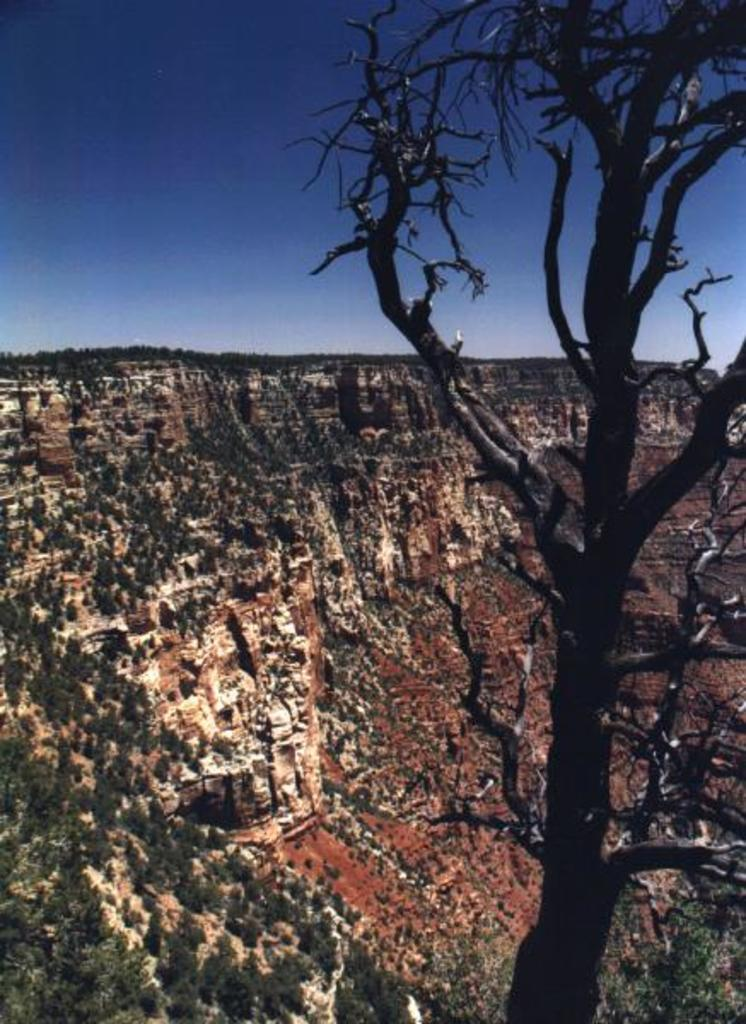What type of vegetation is located on the right side of the image? There is a tree on the right side of the image. What geographical feature can be seen in the background of the image? There is a mountain in the background of the image. How are the trees distributed on the mountain? The mountain is covered with trees. What is visible at the top of the image? The sky is visible at the top of the image. What decision did the coast make in the image? There is no coast or decision-making entity present in the image. Is the actor visible in the image? There is no actor present in the image. 